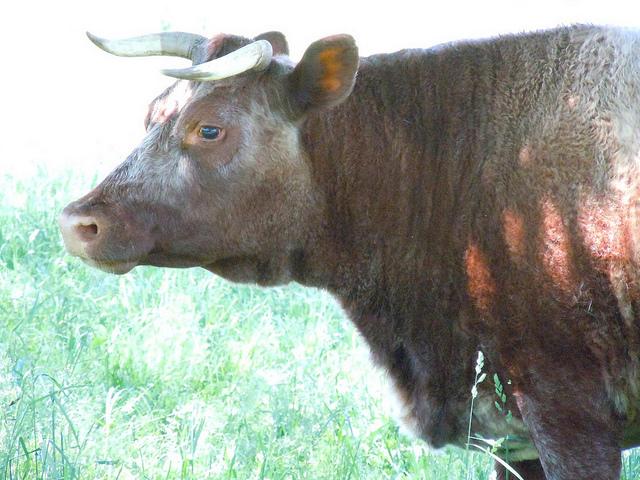What kind of animal is this?
Write a very short answer. Cow. Is this animal a source of milk?
Concise answer only. No. Does this animal have horns?
Quick response, please. Yes. 